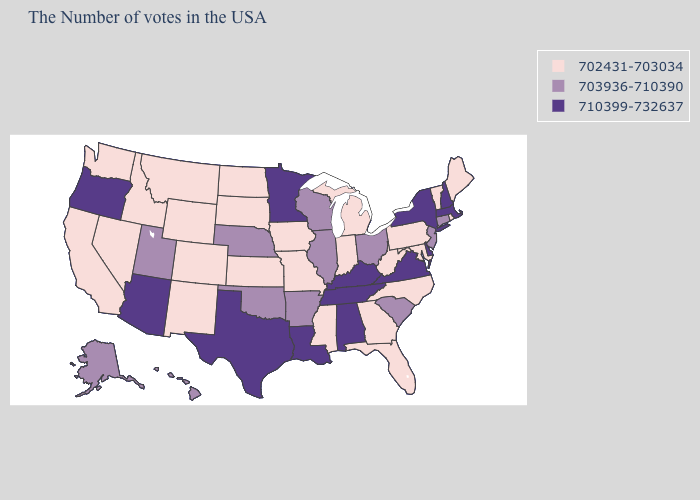Among the states that border Louisiana , does Arkansas have the highest value?
Concise answer only. No. What is the lowest value in states that border West Virginia?
Write a very short answer. 702431-703034. How many symbols are there in the legend?
Short answer required. 3. Among the states that border Maryland , which have the highest value?
Give a very brief answer. Delaware, Virginia. Does Nebraska have the same value as Pennsylvania?
Quick response, please. No. Does the map have missing data?
Answer briefly. No. What is the value of Michigan?
Give a very brief answer. 702431-703034. Does New Hampshire have the lowest value in the Northeast?
Answer briefly. No. What is the lowest value in the USA?
Give a very brief answer. 702431-703034. Name the states that have a value in the range 703936-710390?
Answer briefly. Connecticut, New Jersey, South Carolina, Ohio, Wisconsin, Illinois, Arkansas, Nebraska, Oklahoma, Utah, Alaska, Hawaii. Name the states that have a value in the range 702431-703034?
Be succinct. Maine, Rhode Island, Vermont, Maryland, Pennsylvania, North Carolina, West Virginia, Florida, Georgia, Michigan, Indiana, Mississippi, Missouri, Iowa, Kansas, South Dakota, North Dakota, Wyoming, Colorado, New Mexico, Montana, Idaho, Nevada, California, Washington. What is the highest value in the West ?
Be succinct. 710399-732637. Name the states that have a value in the range 702431-703034?
Give a very brief answer. Maine, Rhode Island, Vermont, Maryland, Pennsylvania, North Carolina, West Virginia, Florida, Georgia, Michigan, Indiana, Mississippi, Missouri, Iowa, Kansas, South Dakota, North Dakota, Wyoming, Colorado, New Mexico, Montana, Idaho, Nevada, California, Washington. Does Illinois have the lowest value in the USA?
Answer briefly. No. 